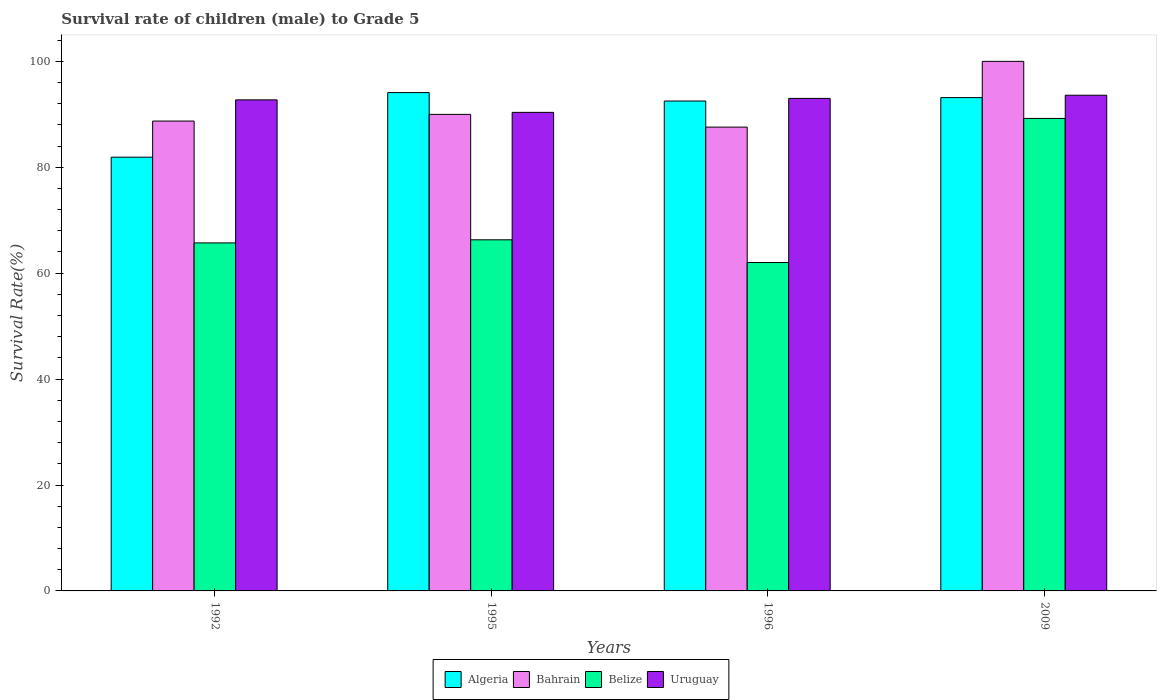Are the number of bars per tick equal to the number of legend labels?
Ensure brevity in your answer.  Yes. Are the number of bars on each tick of the X-axis equal?
Keep it short and to the point. Yes. How many bars are there on the 1st tick from the left?
Provide a succinct answer. 4. What is the label of the 2nd group of bars from the left?
Provide a succinct answer. 1995. In how many cases, is the number of bars for a given year not equal to the number of legend labels?
Offer a very short reply. 0. What is the survival rate of male children to grade 5 in Belize in 2009?
Keep it short and to the point. 89.22. Across all years, what is the maximum survival rate of male children to grade 5 in Uruguay?
Provide a short and direct response. 93.6. Across all years, what is the minimum survival rate of male children to grade 5 in Belize?
Provide a succinct answer. 62.01. In which year was the survival rate of male children to grade 5 in Bahrain maximum?
Provide a short and direct response. 2009. What is the total survival rate of male children to grade 5 in Belize in the graph?
Your answer should be compact. 283.25. What is the difference between the survival rate of male children to grade 5 in Algeria in 1995 and that in 1996?
Your answer should be very brief. 1.59. What is the difference between the survival rate of male children to grade 5 in Bahrain in 1992 and the survival rate of male children to grade 5 in Uruguay in 2009?
Your answer should be very brief. -4.88. What is the average survival rate of male children to grade 5 in Uruguay per year?
Provide a short and direct response. 92.43. In the year 2009, what is the difference between the survival rate of male children to grade 5 in Bahrain and survival rate of male children to grade 5 in Algeria?
Provide a short and direct response. 6.84. What is the ratio of the survival rate of male children to grade 5 in Bahrain in 1996 to that in 2009?
Your answer should be very brief. 0.88. Is the survival rate of male children to grade 5 in Algeria in 1996 less than that in 2009?
Give a very brief answer. Yes. What is the difference between the highest and the second highest survival rate of male children to grade 5 in Uruguay?
Provide a succinct answer. 0.6. What is the difference between the highest and the lowest survival rate of male children to grade 5 in Algeria?
Ensure brevity in your answer.  12.2. What does the 4th bar from the left in 1996 represents?
Give a very brief answer. Uruguay. What does the 1st bar from the right in 1996 represents?
Give a very brief answer. Uruguay. Are all the bars in the graph horizontal?
Your answer should be very brief. No. What is the difference between two consecutive major ticks on the Y-axis?
Provide a short and direct response. 20. Does the graph contain grids?
Give a very brief answer. No. Where does the legend appear in the graph?
Your answer should be very brief. Bottom center. How many legend labels are there?
Your answer should be very brief. 4. How are the legend labels stacked?
Your answer should be compact. Horizontal. What is the title of the graph?
Give a very brief answer. Survival rate of children (male) to Grade 5. Does "Nigeria" appear as one of the legend labels in the graph?
Your response must be concise. No. What is the label or title of the X-axis?
Offer a terse response. Years. What is the label or title of the Y-axis?
Ensure brevity in your answer.  Survival Rate(%). What is the Survival Rate(%) of Algeria in 1992?
Offer a very short reply. 81.9. What is the Survival Rate(%) in Bahrain in 1992?
Offer a very short reply. 88.73. What is the Survival Rate(%) of Belize in 1992?
Keep it short and to the point. 65.72. What is the Survival Rate(%) in Uruguay in 1992?
Provide a short and direct response. 92.73. What is the Survival Rate(%) in Algeria in 1995?
Provide a succinct answer. 94.1. What is the Survival Rate(%) of Bahrain in 1995?
Ensure brevity in your answer.  89.99. What is the Survival Rate(%) of Belize in 1995?
Give a very brief answer. 66.3. What is the Survival Rate(%) of Uruguay in 1995?
Keep it short and to the point. 90.37. What is the Survival Rate(%) of Algeria in 1996?
Ensure brevity in your answer.  92.51. What is the Survival Rate(%) of Bahrain in 1996?
Keep it short and to the point. 87.59. What is the Survival Rate(%) of Belize in 1996?
Offer a terse response. 62.01. What is the Survival Rate(%) in Uruguay in 1996?
Give a very brief answer. 93.01. What is the Survival Rate(%) of Algeria in 2009?
Give a very brief answer. 93.16. What is the Survival Rate(%) in Bahrain in 2009?
Your answer should be compact. 100. What is the Survival Rate(%) in Belize in 2009?
Make the answer very short. 89.22. What is the Survival Rate(%) in Uruguay in 2009?
Provide a succinct answer. 93.6. Across all years, what is the maximum Survival Rate(%) in Algeria?
Offer a terse response. 94.1. Across all years, what is the maximum Survival Rate(%) of Belize?
Provide a short and direct response. 89.22. Across all years, what is the maximum Survival Rate(%) in Uruguay?
Your response must be concise. 93.6. Across all years, what is the minimum Survival Rate(%) of Algeria?
Your response must be concise. 81.9. Across all years, what is the minimum Survival Rate(%) of Bahrain?
Provide a short and direct response. 87.59. Across all years, what is the minimum Survival Rate(%) of Belize?
Your response must be concise. 62.01. Across all years, what is the minimum Survival Rate(%) of Uruguay?
Offer a terse response. 90.37. What is the total Survival Rate(%) of Algeria in the graph?
Provide a short and direct response. 361.67. What is the total Survival Rate(%) in Bahrain in the graph?
Offer a very short reply. 366.3. What is the total Survival Rate(%) of Belize in the graph?
Offer a terse response. 283.25. What is the total Survival Rate(%) of Uruguay in the graph?
Provide a succinct answer. 369.7. What is the difference between the Survival Rate(%) of Algeria in 1992 and that in 1995?
Provide a succinct answer. -12.2. What is the difference between the Survival Rate(%) of Bahrain in 1992 and that in 1995?
Offer a terse response. -1.26. What is the difference between the Survival Rate(%) of Belize in 1992 and that in 1995?
Keep it short and to the point. -0.58. What is the difference between the Survival Rate(%) in Uruguay in 1992 and that in 1995?
Offer a very short reply. 2.36. What is the difference between the Survival Rate(%) in Algeria in 1992 and that in 1996?
Your answer should be very brief. -10.6. What is the difference between the Survival Rate(%) of Bahrain in 1992 and that in 1996?
Your answer should be compact. 1.14. What is the difference between the Survival Rate(%) of Belize in 1992 and that in 1996?
Provide a short and direct response. 3.7. What is the difference between the Survival Rate(%) of Uruguay in 1992 and that in 1996?
Provide a succinct answer. -0.28. What is the difference between the Survival Rate(%) of Algeria in 1992 and that in 2009?
Offer a terse response. -11.25. What is the difference between the Survival Rate(%) of Bahrain in 1992 and that in 2009?
Provide a succinct answer. -11.27. What is the difference between the Survival Rate(%) of Belize in 1992 and that in 2009?
Provide a short and direct response. -23.5. What is the difference between the Survival Rate(%) of Uruguay in 1992 and that in 2009?
Offer a terse response. -0.88. What is the difference between the Survival Rate(%) of Algeria in 1995 and that in 1996?
Provide a short and direct response. 1.59. What is the difference between the Survival Rate(%) in Bahrain in 1995 and that in 1996?
Provide a short and direct response. 2.4. What is the difference between the Survival Rate(%) in Belize in 1995 and that in 1996?
Offer a very short reply. 4.29. What is the difference between the Survival Rate(%) of Uruguay in 1995 and that in 1996?
Keep it short and to the point. -2.64. What is the difference between the Survival Rate(%) of Algeria in 1995 and that in 2009?
Provide a short and direct response. 0.95. What is the difference between the Survival Rate(%) in Bahrain in 1995 and that in 2009?
Provide a short and direct response. -10.01. What is the difference between the Survival Rate(%) of Belize in 1995 and that in 2009?
Offer a terse response. -22.92. What is the difference between the Survival Rate(%) in Uruguay in 1995 and that in 2009?
Make the answer very short. -3.24. What is the difference between the Survival Rate(%) in Algeria in 1996 and that in 2009?
Give a very brief answer. -0.65. What is the difference between the Survival Rate(%) of Bahrain in 1996 and that in 2009?
Your response must be concise. -12.41. What is the difference between the Survival Rate(%) of Belize in 1996 and that in 2009?
Make the answer very short. -27.21. What is the difference between the Survival Rate(%) of Uruguay in 1996 and that in 2009?
Your response must be concise. -0.6. What is the difference between the Survival Rate(%) of Algeria in 1992 and the Survival Rate(%) of Bahrain in 1995?
Your answer should be compact. -8.08. What is the difference between the Survival Rate(%) of Algeria in 1992 and the Survival Rate(%) of Belize in 1995?
Offer a terse response. 15.6. What is the difference between the Survival Rate(%) of Algeria in 1992 and the Survival Rate(%) of Uruguay in 1995?
Your answer should be very brief. -8.46. What is the difference between the Survival Rate(%) in Bahrain in 1992 and the Survival Rate(%) in Belize in 1995?
Your answer should be compact. 22.43. What is the difference between the Survival Rate(%) of Bahrain in 1992 and the Survival Rate(%) of Uruguay in 1995?
Ensure brevity in your answer.  -1.64. What is the difference between the Survival Rate(%) of Belize in 1992 and the Survival Rate(%) of Uruguay in 1995?
Provide a succinct answer. -24.65. What is the difference between the Survival Rate(%) of Algeria in 1992 and the Survival Rate(%) of Bahrain in 1996?
Offer a very short reply. -5.68. What is the difference between the Survival Rate(%) in Algeria in 1992 and the Survival Rate(%) in Belize in 1996?
Provide a short and direct response. 19.89. What is the difference between the Survival Rate(%) of Algeria in 1992 and the Survival Rate(%) of Uruguay in 1996?
Provide a short and direct response. -11.1. What is the difference between the Survival Rate(%) in Bahrain in 1992 and the Survival Rate(%) in Belize in 1996?
Your response must be concise. 26.71. What is the difference between the Survival Rate(%) in Bahrain in 1992 and the Survival Rate(%) in Uruguay in 1996?
Give a very brief answer. -4.28. What is the difference between the Survival Rate(%) of Belize in 1992 and the Survival Rate(%) of Uruguay in 1996?
Offer a terse response. -27.29. What is the difference between the Survival Rate(%) of Algeria in 1992 and the Survival Rate(%) of Bahrain in 2009?
Make the answer very short. -18.1. What is the difference between the Survival Rate(%) in Algeria in 1992 and the Survival Rate(%) in Belize in 2009?
Ensure brevity in your answer.  -7.32. What is the difference between the Survival Rate(%) in Algeria in 1992 and the Survival Rate(%) in Uruguay in 2009?
Make the answer very short. -11.7. What is the difference between the Survival Rate(%) in Bahrain in 1992 and the Survival Rate(%) in Belize in 2009?
Offer a very short reply. -0.49. What is the difference between the Survival Rate(%) in Bahrain in 1992 and the Survival Rate(%) in Uruguay in 2009?
Offer a very short reply. -4.88. What is the difference between the Survival Rate(%) in Belize in 1992 and the Survival Rate(%) in Uruguay in 2009?
Ensure brevity in your answer.  -27.89. What is the difference between the Survival Rate(%) of Algeria in 1995 and the Survival Rate(%) of Bahrain in 1996?
Provide a short and direct response. 6.52. What is the difference between the Survival Rate(%) in Algeria in 1995 and the Survival Rate(%) in Belize in 1996?
Provide a succinct answer. 32.09. What is the difference between the Survival Rate(%) in Algeria in 1995 and the Survival Rate(%) in Uruguay in 1996?
Your answer should be very brief. 1.1. What is the difference between the Survival Rate(%) in Bahrain in 1995 and the Survival Rate(%) in Belize in 1996?
Your answer should be compact. 27.97. What is the difference between the Survival Rate(%) in Bahrain in 1995 and the Survival Rate(%) in Uruguay in 1996?
Provide a short and direct response. -3.02. What is the difference between the Survival Rate(%) of Belize in 1995 and the Survival Rate(%) of Uruguay in 1996?
Make the answer very short. -26.7. What is the difference between the Survival Rate(%) of Algeria in 1995 and the Survival Rate(%) of Bahrain in 2009?
Make the answer very short. -5.9. What is the difference between the Survival Rate(%) of Algeria in 1995 and the Survival Rate(%) of Belize in 2009?
Ensure brevity in your answer.  4.88. What is the difference between the Survival Rate(%) in Algeria in 1995 and the Survival Rate(%) in Uruguay in 2009?
Provide a short and direct response. 0.5. What is the difference between the Survival Rate(%) in Bahrain in 1995 and the Survival Rate(%) in Belize in 2009?
Provide a short and direct response. 0.76. What is the difference between the Survival Rate(%) of Bahrain in 1995 and the Survival Rate(%) of Uruguay in 2009?
Keep it short and to the point. -3.62. What is the difference between the Survival Rate(%) of Belize in 1995 and the Survival Rate(%) of Uruguay in 2009?
Provide a succinct answer. -27.3. What is the difference between the Survival Rate(%) in Algeria in 1996 and the Survival Rate(%) in Bahrain in 2009?
Offer a terse response. -7.49. What is the difference between the Survival Rate(%) of Algeria in 1996 and the Survival Rate(%) of Belize in 2009?
Give a very brief answer. 3.29. What is the difference between the Survival Rate(%) in Algeria in 1996 and the Survival Rate(%) in Uruguay in 2009?
Provide a short and direct response. -1.09. What is the difference between the Survival Rate(%) in Bahrain in 1996 and the Survival Rate(%) in Belize in 2009?
Give a very brief answer. -1.64. What is the difference between the Survival Rate(%) of Bahrain in 1996 and the Survival Rate(%) of Uruguay in 2009?
Keep it short and to the point. -6.02. What is the difference between the Survival Rate(%) in Belize in 1996 and the Survival Rate(%) in Uruguay in 2009?
Offer a very short reply. -31.59. What is the average Survival Rate(%) in Algeria per year?
Provide a short and direct response. 90.42. What is the average Survival Rate(%) of Bahrain per year?
Make the answer very short. 91.57. What is the average Survival Rate(%) of Belize per year?
Give a very brief answer. 70.81. What is the average Survival Rate(%) of Uruguay per year?
Offer a very short reply. 92.43. In the year 1992, what is the difference between the Survival Rate(%) in Algeria and Survival Rate(%) in Bahrain?
Offer a terse response. -6.82. In the year 1992, what is the difference between the Survival Rate(%) in Algeria and Survival Rate(%) in Belize?
Ensure brevity in your answer.  16.19. In the year 1992, what is the difference between the Survival Rate(%) of Algeria and Survival Rate(%) of Uruguay?
Offer a very short reply. -10.82. In the year 1992, what is the difference between the Survival Rate(%) in Bahrain and Survival Rate(%) in Belize?
Give a very brief answer. 23.01. In the year 1992, what is the difference between the Survival Rate(%) of Bahrain and Survival Rate(%) of Uruguay?
Your response must be concise. -4. In the year 1992, what is the difference between the Survival Rate(%) in Belize and Survival Rate(%) in Uruguay?
Your answer should be very brief. -27.01. In the year 1995, what is the difference between the Survival Rate(%) in Algeria and Survival Rate(%) in Bahrain?
Your answer should be very brief. 4.12. In the year 1995, what is the difference between the Survival Rate(%) in Algeria and Survival Rate(%) in Belize?
Your answer should be very brief. 27.8. In the year 1995, what is the difference between the Survival Rate(%) of Algeria and Survival Rate(%) of Uruguay?
Give a very brief answer. 3.73. In the year 1995, what is the difference between the Survival Rate(%) in Bahrain and Survival Rate(%) in Belize?
Offer a very short reply. 23.68. In the year 1995, what is the difference between the Survival Rate(%) in Bahrain and Survival Rate(%) in Uruguay?
Provide a short and direct response. -0.38. In the year 1995, what is the difference between the Survival Rate(%) of Belize and Survival Rate(%) of Uruguay?
Offer a very short reply. -24.07. In the year 1996, what is the difference between the Survival Rate(%) in Algeria and Survival Rate(%) in Bahrain?
Your answer should be very brief. 4.92. In the year 1996, what is the difference between the Survival Rate(%) of Algeria and Survival Rate(%) of Belize?
Keep it short and to the point. 30.5. In the year 1996, what is the difference between the Survival Rate(%) in Algeria and Survival Rate(%) in Uruguay?
Your answer should be compact. -0.5. In the year 1996, what is the difference between the Survival Rate(%) in Bahrain and Survival Rate(%) in Belize?
Offer a very short reply. 25.57. In the year 1996, what is the difference between the Survival Rate(%) of Bahrain and Survival Rate(%) of Uruguay?
Offer a very short reply. -5.42. In the year 1996, what is the difference between the Survival Rate(%) of Belize and Survival Rate(%) of Uruguay?
Offer a terse response. -30.99. In the year 2009, what is the difference between the Survival Rate(%) in Algeria and Survival Rate(%) in Bahrain?
Ensure brevity in your answer.  -6.84. In the year 2009, what is the difference between the Survival Rate(%) in Algeria and Survival Rate(%) in Belize?
Offer a very short reply. 3.93. In the year 2009, what is the difference between the Survival Rate(%) of Algeria and Survival Rate(%) of Uruguay?
Provide a short and direct response. -0.45. In the year 2009, what is the difference between the Survival Rate(%) of Bahrain and Survival Rate(%) of Belize?
Ensure brevity in your answer.  10.78. In the year 2009, what is the difference between the Survival Rate(%) of Bahrain and Survival Rate(%) of Uruguay?
Your answer should be compact. 6.4. In the year 2009, what is the difference between the Survival Rate(%) of Belize and Survival Rate(%) of Uruguay?
Provide a short and direct response. -4.38. What is the ratio of the Survival Rate(%) of Algeria in 1992 to that in 1995?
Offer a very short reply. 0.87. What is the ratio of the Survival Rate(%) of Bahrain in 1992 to that in 1995?
Make the answer very short. 0.99. What is the ratio of the Survival Rate(%) in Uruguay in 1992 to that in 1995?
Ensure brevity in your answer.  1.03. What is the ratio of the Survival Rate(%) in Algeria in 1992 to that in 1996?
Make the answer very short. 0.89. What is the ratio of the Survival Rate(%) of Belize in 1992 to that in 1996?
Your answer should be very brief. 1.06. What is the ratio of the Survival Rate(%) of Uruguay in 1992 to that in 1996?
Give a very brief answer. 1. What is the ratio of the Survival Rate(%) of Algeria in 1992 to that in 2009?
Provide a short and direct response. 0.88. What is the ratio of the Survival Rate(%) of Bahrain in 1992 to that in 2009?
Your answer should be compact. 0.89. What is the ratio of the Survival Rate(%) in Belize in 1992 to that in 2009?
Ensure brevity in your answer.  0.74. What is the ratio of the Survival Rate(%) of Uruguay in 1992 to that in 2009?
Ensure brevity in your answer.  0.99. What is the ratio of the Survival Rate(%) in Algeria in 1995 to that in 1996?
Keep it short and to the point. 1.02. What is the ratio of the Survival Rate(%) in Bahrain in 1995 to that in 1996?
Offer a very short reply. 1.03. What is the ratio of the Survival Rate(%) of Belize in 1995 to that in 1996?
Offer a very short reply. 1.07. What is the ratio of the Survival Rate(%) in Uruguay in 1995 to that in 1996?
Give a very brief answer. 0.97. What is the ratio of the Survival Rate(%) of Algeria in 1995 to that in 2009?
Your response must be concise. 1.01. What is the ratio of the Survival Rate(%) in Bahrain in 1995 to that in 2009?
Provide a succinct answer. 0.9. What is the ratio of the Survival Rate(%) in Belize in 1995 to that in 2009?
Keep it short and to the point. 0.74. What is the ratio of the Survival Rate(%) of Uruguay in 1995 to that in 2009?
Ensure brevity in your answer.  0.97. What is the ratio of the Survival Rate(%) in Algeria in 1996 to that in 2009?
Make the answer very short. 0.99. What is the ratio of the Survival Rate(%) in Bahrain in 1996 to that in 2009?
Offer a terse response. 0.88. What is the ratio of the Survival Rate(%) of Belize in 1996 to that in 2009?
Offer a terse response. 0.7. What is the ratio of the Survival Rate(%) of Uruguay in 1996 to that in 2009?
Your answer should be very brief. 0.99. What is the difference between the highest and the second highest Survival Rate(%) of Algeria?
Your answer should be compact. 0.95. What is the difference between the highest and the second highest Survival Rate(%) of Bahrain?
Offer a terse response. 10.01. What is the difference between the highest and the second highest Survival Rate(%) in Belize?
Provide a succinct answer. 22.92. What is the difference between the highest and the second highest Survival Rate(%) of Uruguay?
Give a very brief answer. 0.6. What is the difference between the highest and the lowest Survival Rate(%) of Algeria?
Your response must be concise. 12.2. What is the difference between the highest and the lowest Survival Rate(%) in Bahrain?
Provide a succinct answer. 12.41. What is the difference between the highest and the lowest Survival Rate(%) of Belize?
Provide a short and direct response. 27.21. What is the difference between the highest and the lowest Survival Rate(%) in Uruguay?
Provide a short and direct response. 3.24. 